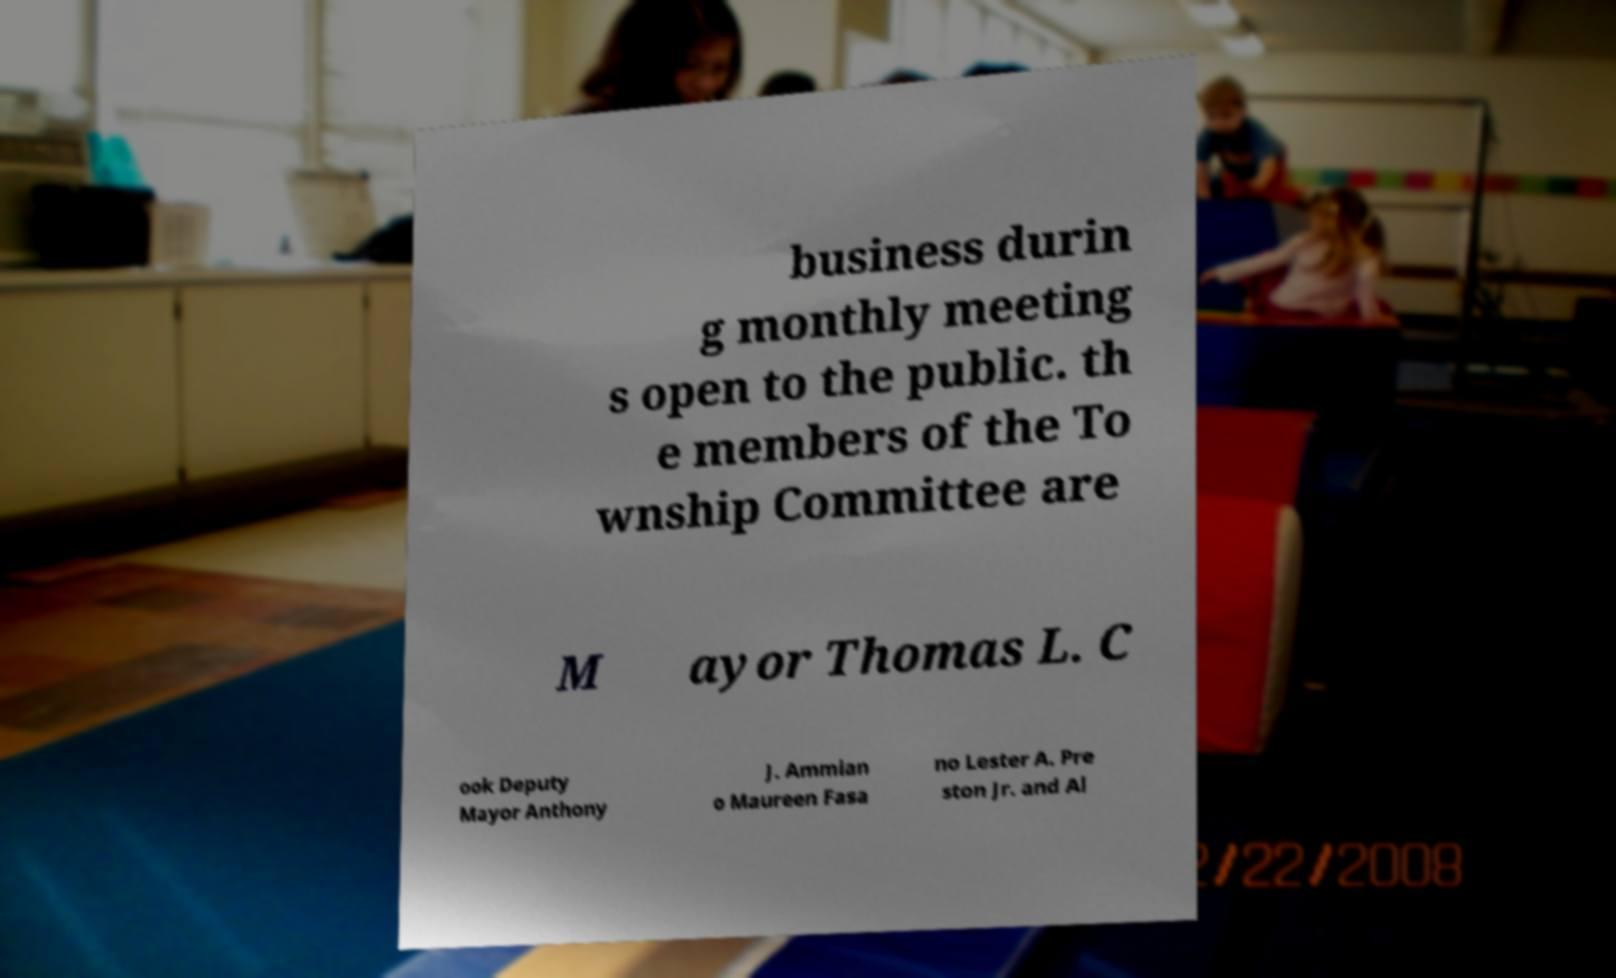For documentation purposes, I need the text within this image transcribed. Could you provide that? business durin g monthly meeting s open to the public. th e members of the To wnship Committee are M ayor Thomas L. C ook Deputy Mayor Anthony J. Ammian o Maureen Fasa no Lester A. Pre ston Jr. and Al 